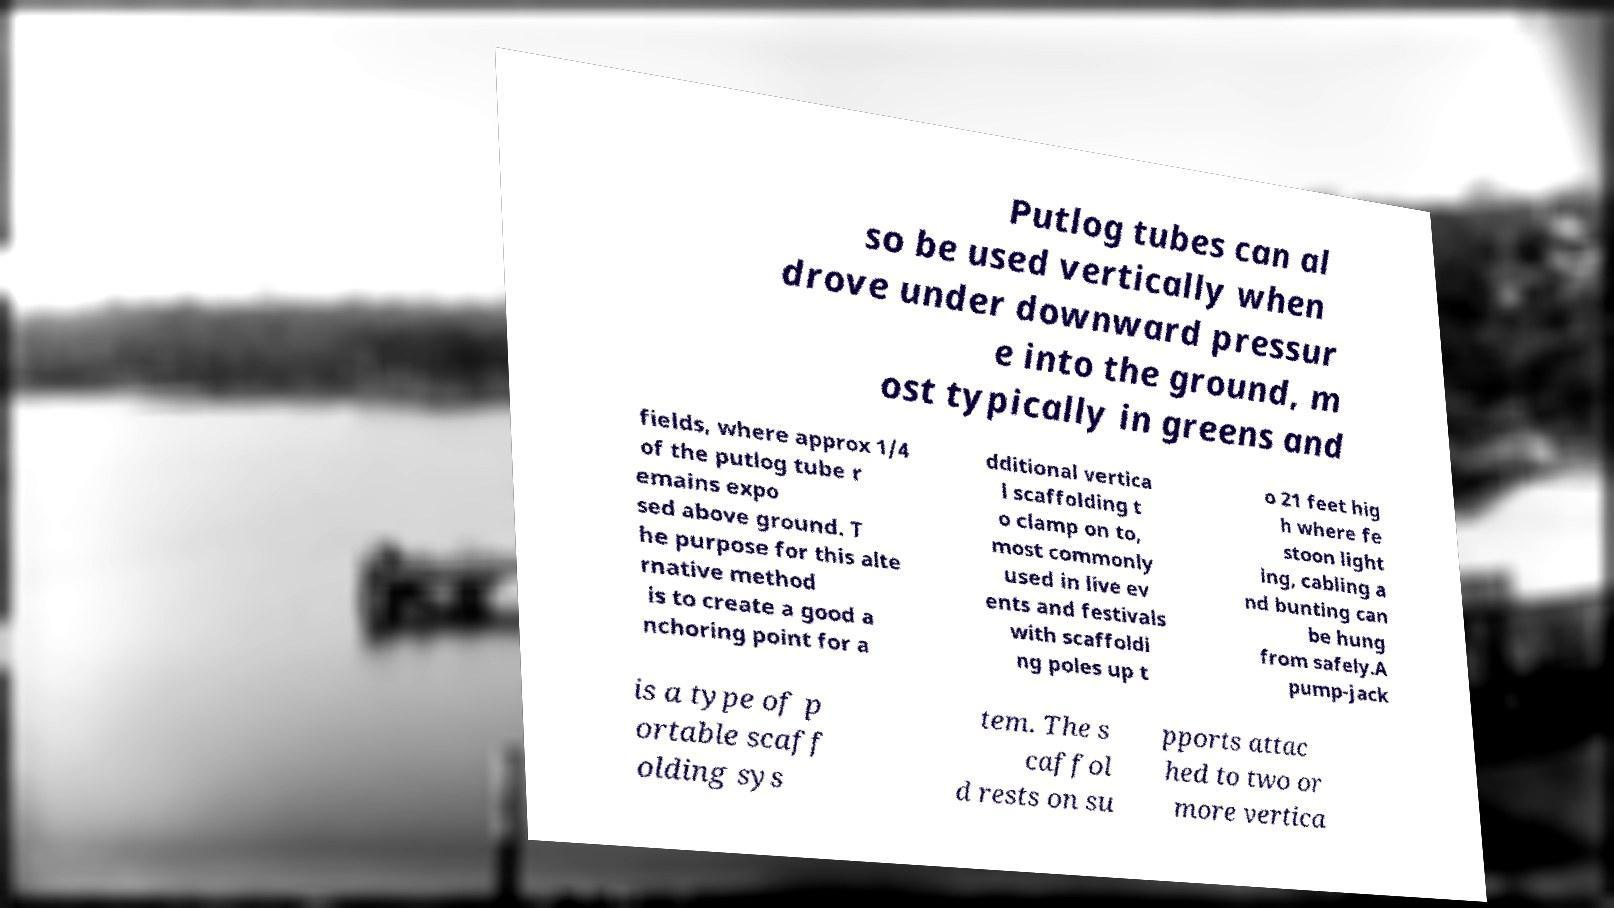For documentation purposes, I need the text within this image transcribed. Could you provide that? Putlog tubes can al so be used vertically when drove under downward pressur e into the ground, m ost typically in greens and fields, where approx 1/4 of the putlog tube r emains expo sed above ground. T he purpose for this alte rnative method is to create a good a nchoring point for a dditional vertica l scaffolding t o clamp on to, most commonly used in live ev ents and festivals with scaffoldi ng poles up t o 21 feet hig h where fe stoon light ing, cabling a nd bunting can be hung from safely.A pump-jack is a type of p ortable scaff olding sys tem. The s caffol d rests on su pports attac hed to two or more vertica 